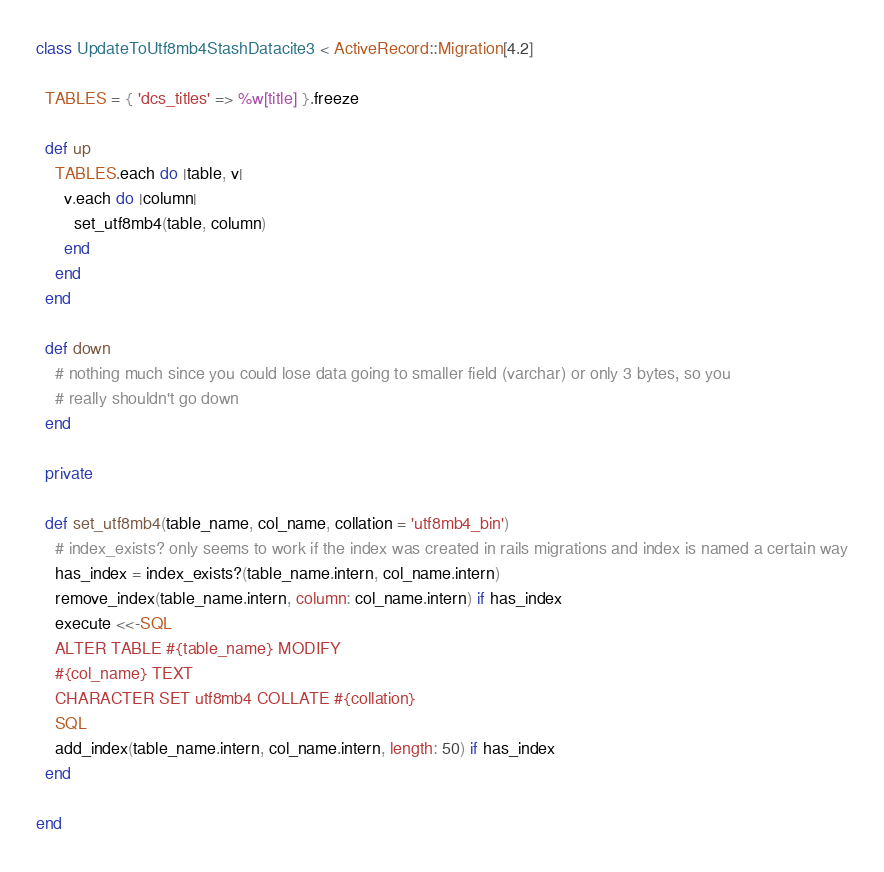Convert code to text. <code><loc_0><loc_0><loc_500><loc_500><_Ruby_>class UpdateToUtf8mb4StashDatacite3 < ActiveRecord::Migration[4.2]

  TABLES = { 'dcs_titles' => %w[title] }.freeze

  def up
    TABLES.each do |table, v|
      v.each do |column|
        set_utf8mb4(table, column)
      end
    end
  end

  def down
    # nothing much since you could lose data going to smaller field (varchar) or only 3 bytes, so you
    # really shouldn't go down
  end

  private

  def set_utf8mb4(table_name, col_name, collation = 'utf8mb4_bin')
    # index_exists? only seems to work if the index was created in rails migrations and index is named a certain way
    has_index = index_exists?(table_name.intern, col_name.intern)
    remove_index(table_name.intern, column: col_name.intern) if has_index
    execute <<-SQL
    ALTER TABLE #{table_name} MODIFY
    #{col_name} TEXT
    CHARACTER SET utf8mb4 COLLATE #{collation}
    SQL
    add_index(table_name.intern, col_name.intern, length: 50) if has_index
  end

end
</code> 